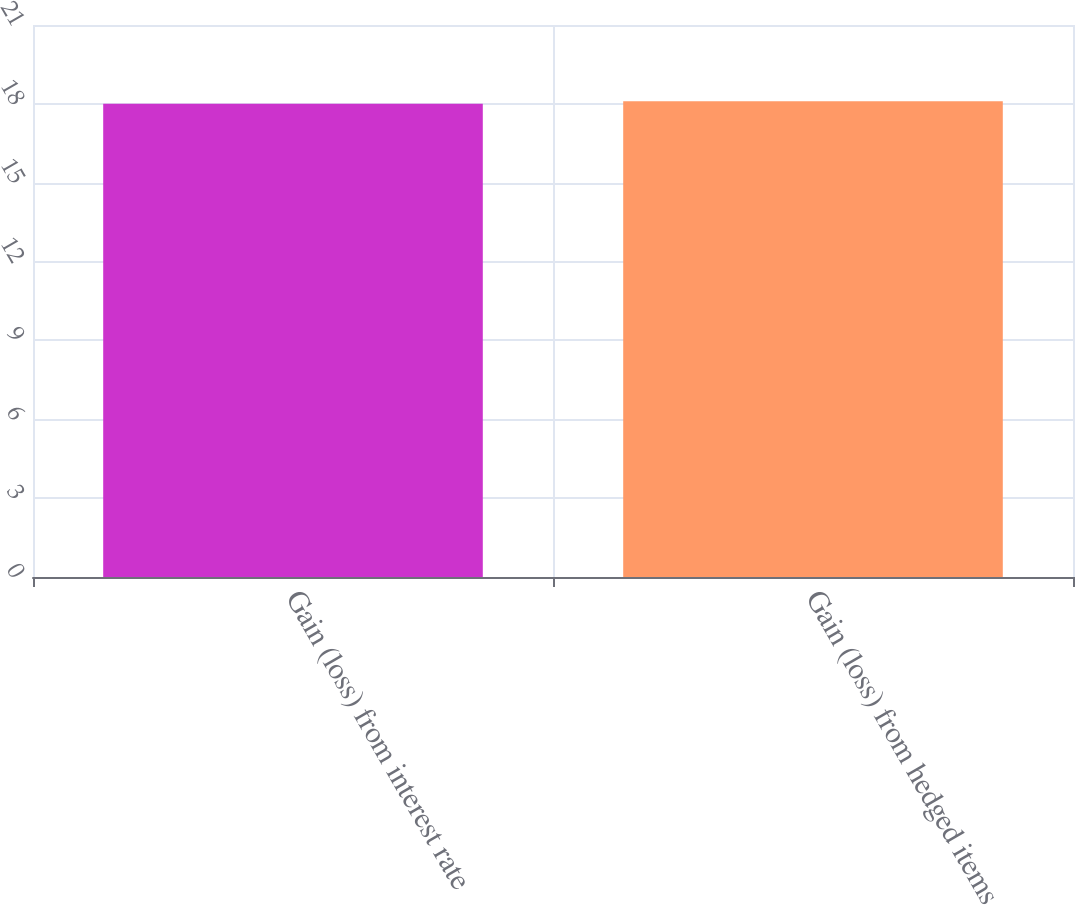Convert chart. <chart><loc_0><loc_0><loc_500><loc_500><bar_chart><fcel>Gain (loss) from interest rate<fcel>Gain (loss) from hedged items<nl><fcel>18<fcel>18.1<nl></chart> 